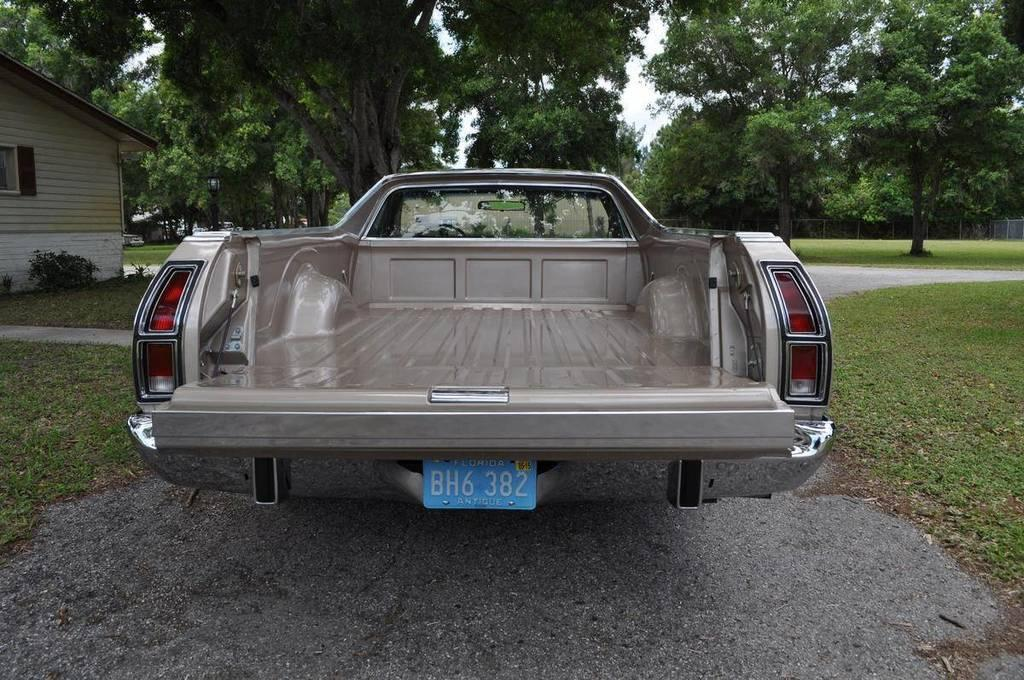What type of vehicle is present in the image? There is a truck with a number plate in the image. What is on the sides of the truck? There are grass lawns on the sides of the truck. What can be seen on the left side of the image? There is a building on the left side of the image. What is visible in the background of the image? There are trees in the background of the image. How many beds can be seen in the image? There are no beds present in the image. What color is the sock on the driver's foot in the image? There is no sock or driver visible in the image; it only shows a truck, grass lawns, a building, and trees. 